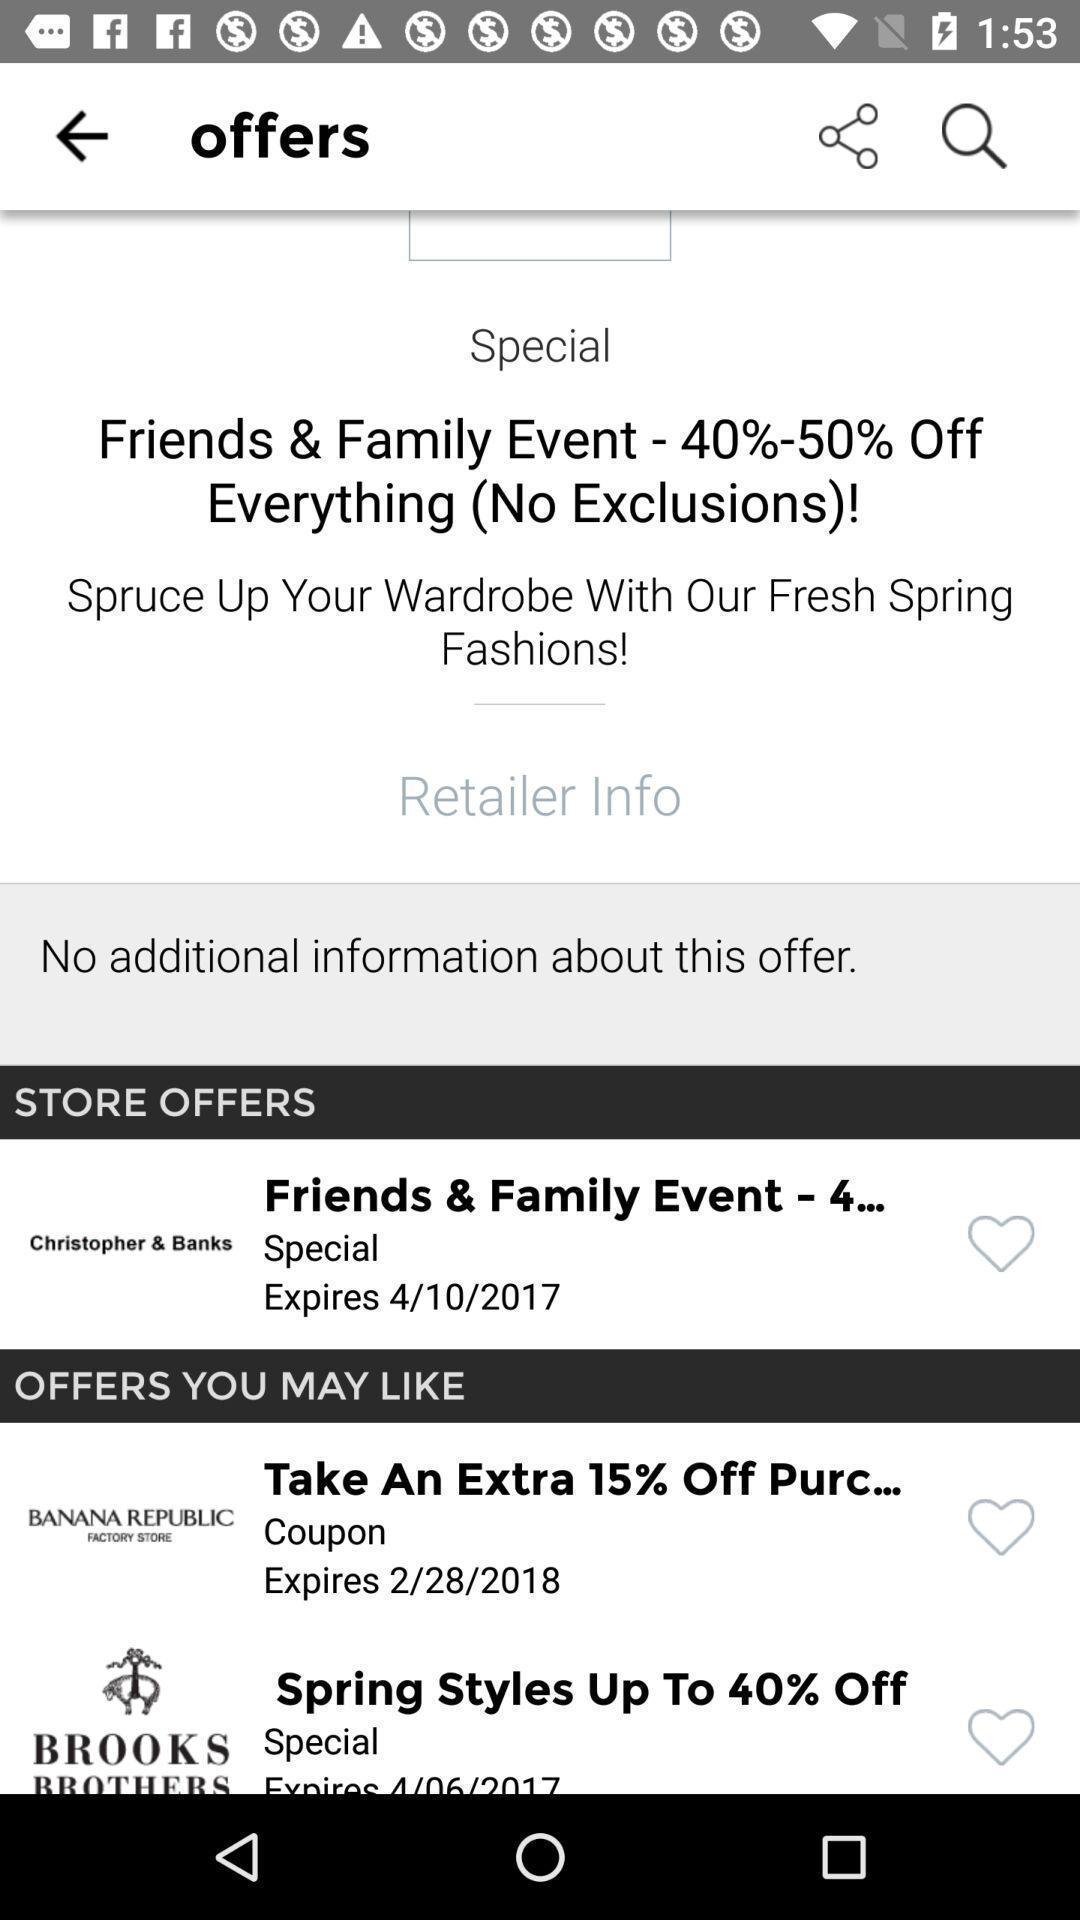Please provide a description for this image. Page showing different options on shopping app. 